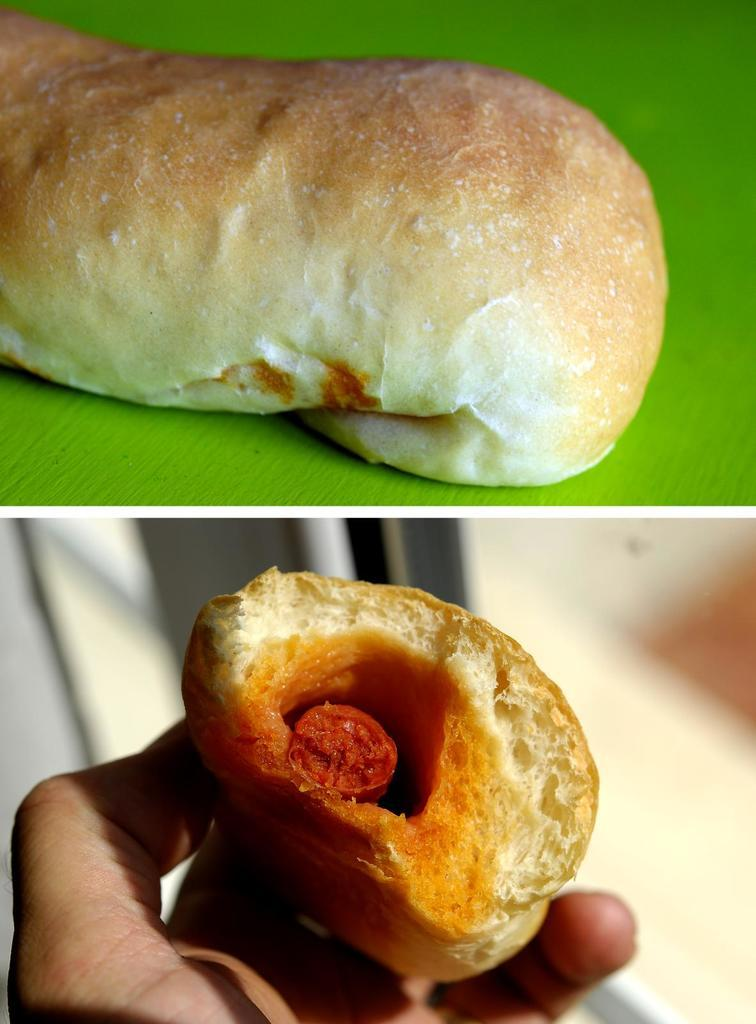How many pictures are included in the collage? The image is a collage containing two pictures. What is depicted in the first picture? In one picture, there is a food item on a plate. What is depicted in the second picture? In another picture, there is a food item in a hand. How many children are wearing jeans in the image? There are no children or jeans present in the image; it contains two pictures of food items. 